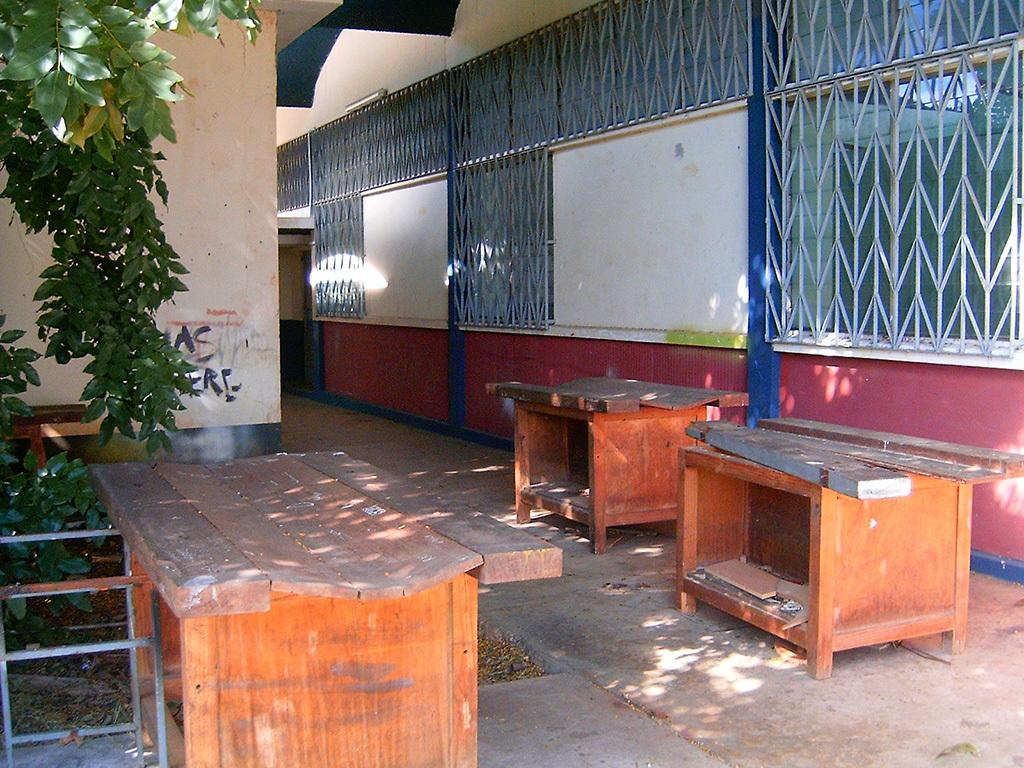What type of furniture is present in the image? There are wooden tables in the image. What natural elements can be seen in the image? There are trees in the left corner of the image. What architectural feature is present in the right corner of the image? There is a fence in the right corner of the image. How many fish can be seen swimming in the image? There are no fish present in the image. What type of knot is tied on the fence in the image? There is no knot visible on the fence in the image. 